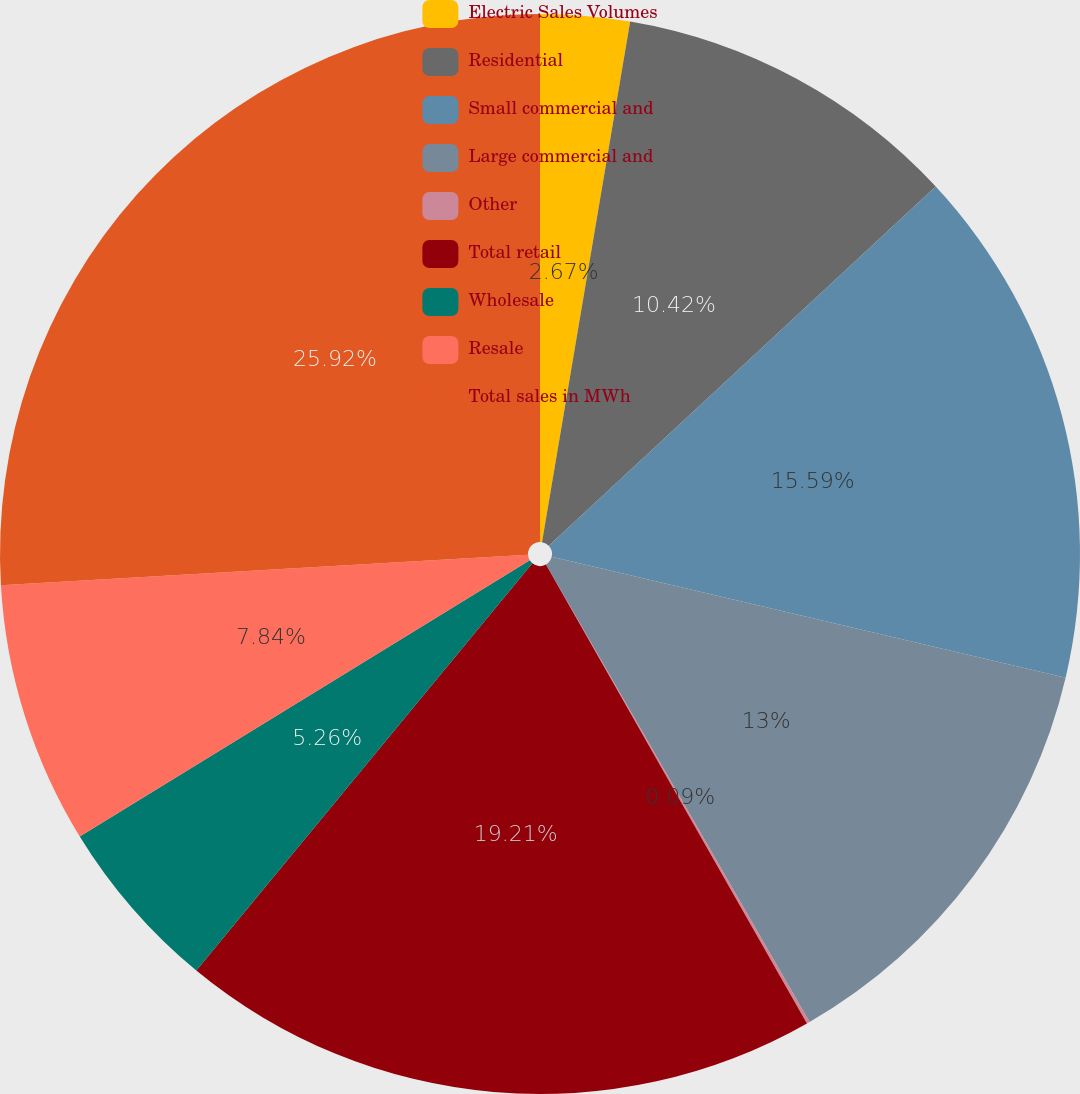<chart> <loc_0><loc_0><loc_500><loc_500><pie_chart><fcel>Electric Sales Volumes<fcel>Residential<fcel>Small commercial and<fcel>Large commercial and<fcel>Other<fcel>Total retail<fcel>Wholesale<fcel>Resale<fcel>Total sales in MWh<nl><fcel>2.67%<fcel>10.42%<fcel>15.59%<fcel>13.0%<fcel>0.09%<fcel>19.21%<fcel>5.26%<fcel>7.84%<fcel>25.92%<nl></chart> 